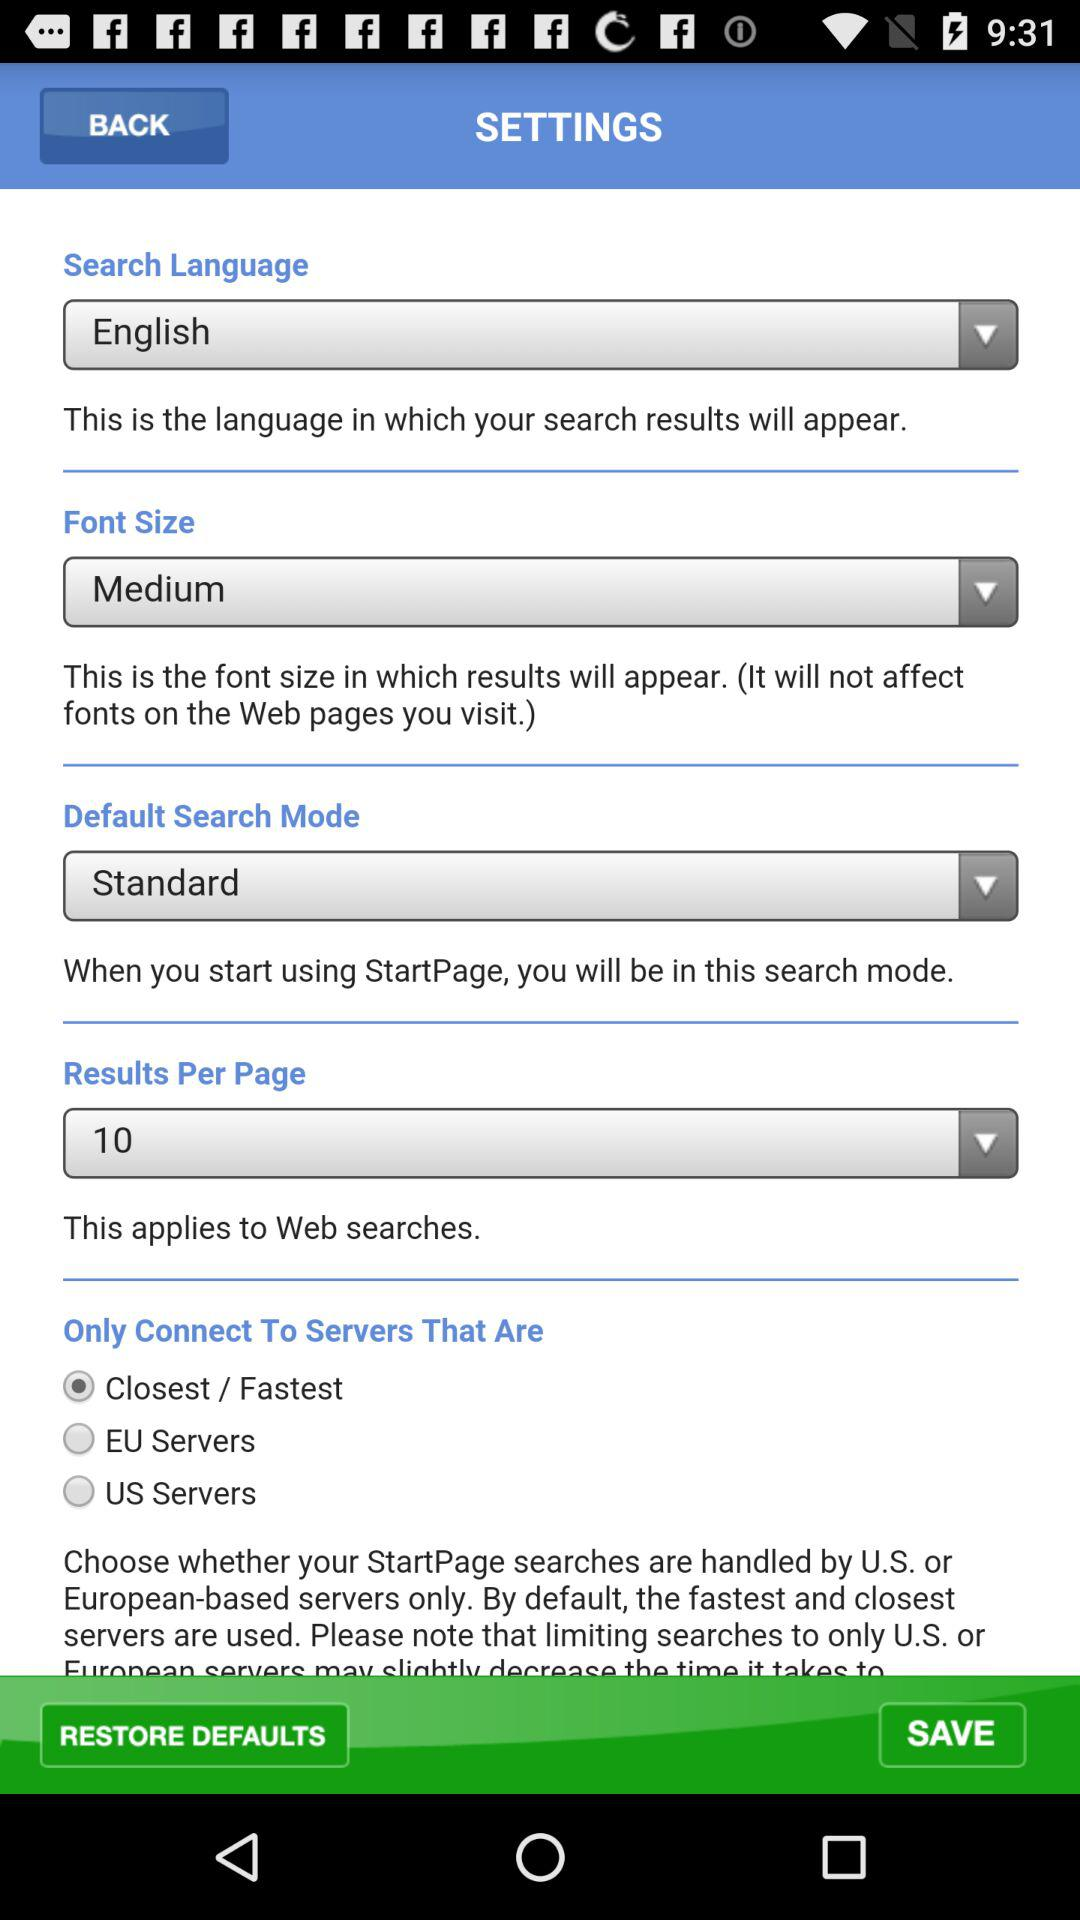Which option is selected in "Only Connect To Servers That Are"? The selected option is "Closest / Fastest". 